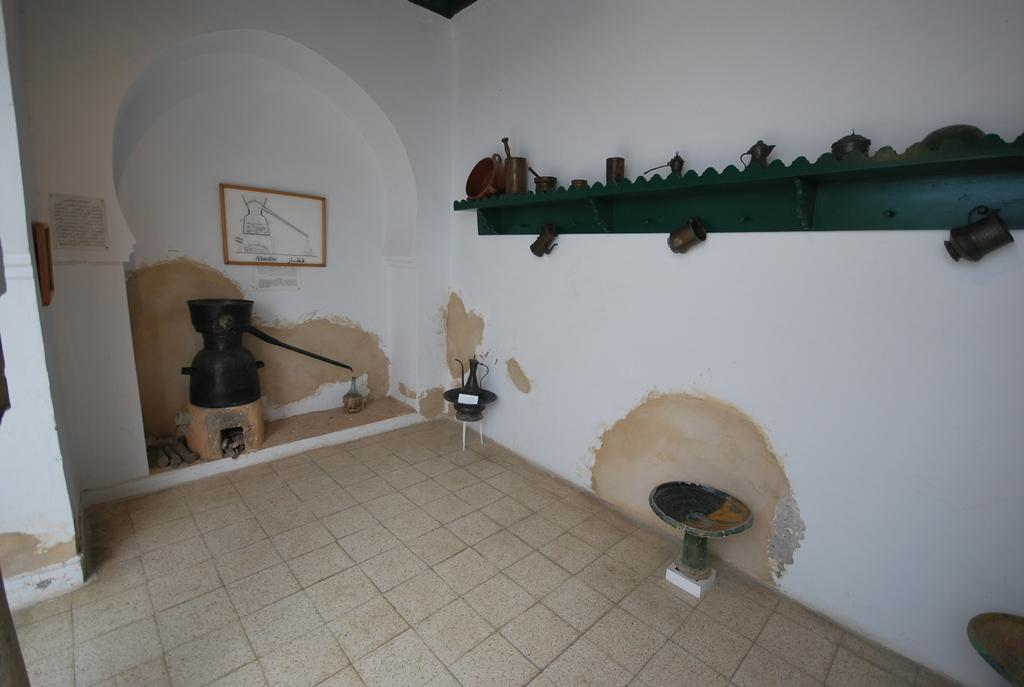What can be found in the room in the image? There are objects in the room. Can you describe a specific item on the wall? There is a photo frame on the wall. What type of platform is present in the image? There is a wooden platform with objects on it. How many slaves are visible in the image? There are no slaves present in the image. What type of nut is being cracked on the wooden platform? There is no nut or nut-cracking activity depicted in the image. 